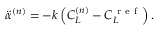<formula> <loc_0><loc_0><loc_500><loc_500>\ddot { \alpha } ^ { ( n ) } = - k \left ( C _ { L } ^ { ( n ) } - C _ { L } ^ { r e f } \right ) .</formula> 